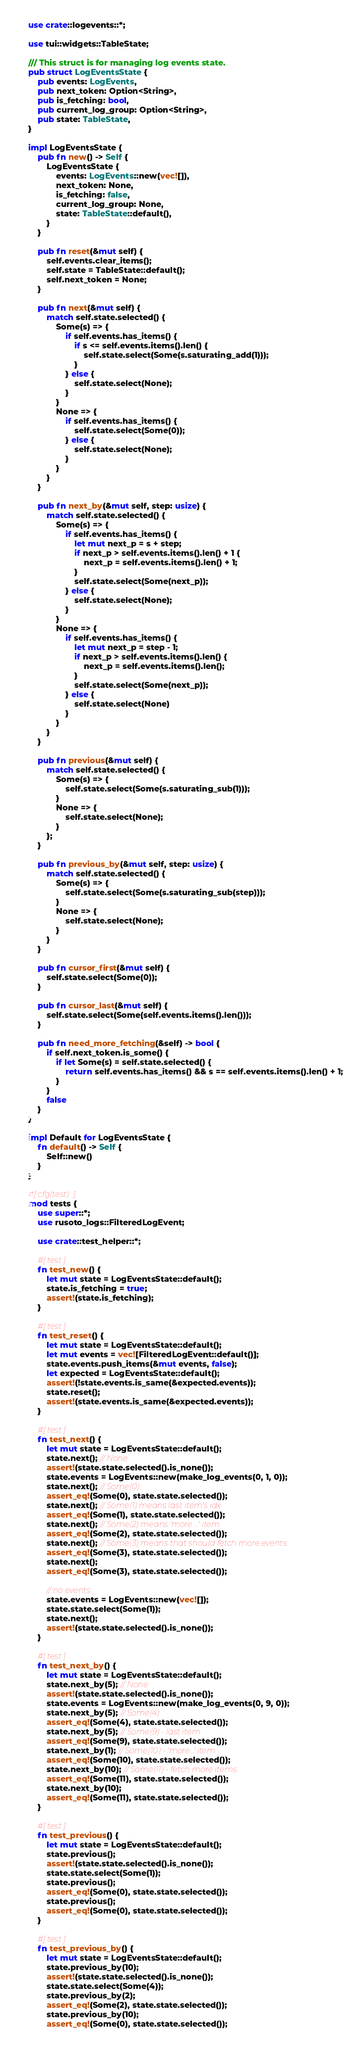<code> <loc_0><loc_0><loc_500><loc_500><_Rust_>use crate::logevents::*;

use tui::widgets::TableState;

/// This struct is for managing log events state.
pub struct LogEventsState {
    pub events: LogEvents,
    pub next_token: Option<String>,
    pub is_fetching: bool,
    pub current_log_group: Option<String>,
    pub state: TableState,
}

impl LogEventsState {
    pub fn new() -> Self {
        LogEventsState {
            events: LogEvents::new(vec![]),
            next_token: None,
            is_fetching: false,
            current_log_group: None,
            state: TableState::default(),
        }
    }

    pub fn reset(&mut self) {
        self.events.clear_items();
        self.state = TableState::default();
        self.next_token = None;
    }

    pub fn next(&mut self) {
        match self.state.selected() {
            Some(s) => {
                if self.events.has_items() {
                    if s <= self.events.items().len() {
                        self.state.select(Some(s.saturating_add(1)));
                    }
                } else {
                    self.state.select(None);
                }
            }
            None => {
                if self.events.has_items() {
                    self.state.select(Some(0));
                } else {
                    self.state.select(None);
                }
            }
        }
    }

    pub fn next_by(&mut self, step: usize) {
        match self.state.selected() {
            Some(s) => {
                if self.events.has_items() {
                    let mut next_p = s + step;
                    if next_p > self.events.items().len() + 1 {
                        next_p = self.events.items().len() + 1;
                    }
                    self.state.select(Some(next_p));
                } else {
                    self.state.select(None);
                }
            }
            None => {
                if self.events.has_items() {
                    let mut next_p = step - 1;
                    if next_p > self.events.items().len() {
                        next_p = self.events.items().len();
                    }
                    self.state.select(Some(next_p));
                } else {
                    self.state.select(None)
                }
            }
        }
    }

    pub fn previous(&mut self) {
        match self.state.selected() {
            Some(s) => {
                self.state.select(Some(s.saturating_sub(1)));
            }
            None => {
                self.state.select(None);
            }
        };
    }

    pub fn previous_by(&mut self, step: usize) {
        match self.state.selected() {
            Some(s) => {
                self.state.select(Some(s.saturating_sub(step)));
            }
            None => {
                self.state.select(None);
            }
        }
    }

    pub fn cursor_first(&mut self) {
        self.state.select(Some(0));
    }

    pub fn cursor_last(&mut self) {
        self.state.select(Some(self.events.items().len()));
    }

    pub fn need_more_fetching(&self) -> bool {
        if self.next_token.is_some() {
            if let Some(s) = self.state.selected() {
                return self.events.has_items() && s == self.events.items().len() + 1;
            }
        }
        false
    }
}

impl Default for LogEventsState {
    fn default() -> Self {
        Self::new()
    }
}

#[cfg(test)]
mod tests {
    use super::*;
    use rusoto_logs::FilteredLogEvent;

    use crate::test_helper::*;

    #[test]
    fn test_new() {
        let mut state = LogEventsState::default();
        state.is_fetching = true;
        assert!(state.is_fetching);
    }

    #[test]
    fn test_reset() {
        let mut state = LogEventsState::default();
        let mut events = vec![FilteredLogEvent::default()];
        state.events.push_items(&mut events, false);
        let expected = LogEventsState::default();
        assert!(!state.events.is_same(&expected.events));
        state.reset();
        assert!(state.events.is_same(&expected.events));
    }

    #[test]
    fn test_next() {
        let mut state = LogEventsState::default();
        state.next(); // None
        assert!(state.state.selected().is_none());
        state.events = LogEvents::new(make_log_events(0, 1, 0));
        state.next(); // Some(0)
        assert_eq!(Some(0), state.state.selected());
        state.next(); // Some(1) means last item's idx
        assert_eq!(Some(1), state.state.selected());
        state.next(); // Some(2) means 'more ...' item
        assert_eq!(Some(2), state.state.selected());
        state.next(); // Some(3) means that should fetch more events
        assert_eq!(Some(3), state.state.selected());
        state.next();
        assert_eq!(Some(3), state.state.selected());

        // no events
        state.events = LogEvents::new(vec![]);
        state.state.select(Some(1));
        state.next();
        assert!(state.state.selected().is_none());
    }

    #[test]
    fn test_next_by() {
        let mut state = LogEventsState::default();
        state.next_by(5); // None
        assert!(state.state.selected().is_none());
        state.events = LogEvents::new(make_log_events(0, 9, 0));
        state.next_by(5); // Some(4)
        assert_eq!(Some(4), state.state.selected());
        state.next_by(5); // Some(9) - last item
        assert_eq!(Some(9), state.state.selected());
        state.next_by(1); // Some(10) - 'more...' item
        assert_eq!(Some(10), state.state.selected());
        state.next_by(10); // Some(11) - fetch more items
        assert_eq!(Some(11), state.state.selected());
        state.next_by(10);
        assert_eq!(Some(11), state.state.selected());
    }

    #[test]
    fn test_previous() {
        let mut state = LogEventsState::default();
        state.previous();
        assert!(state.state.selected().is_none());
        state.state.select(Some(1));
        state.previous();
        assert_eq!(Some(0), state.state.selected());
        state.previous();
        assert_eq!(Some(0), state.state.selected());
    }

    #[test]
    fn test_previous_by() {
        let mut state = LogEventsState::default();
        state.previous_by(10);
        assert!(state.state.selected().is_none());
        state.state.select(Some(4));
        state.previous_by(2);
        assert_eq!(Some(2), state.state.selected());
        state.previous_by(10);
        assert_eq!(Some(0), state.state.selected());</code> 